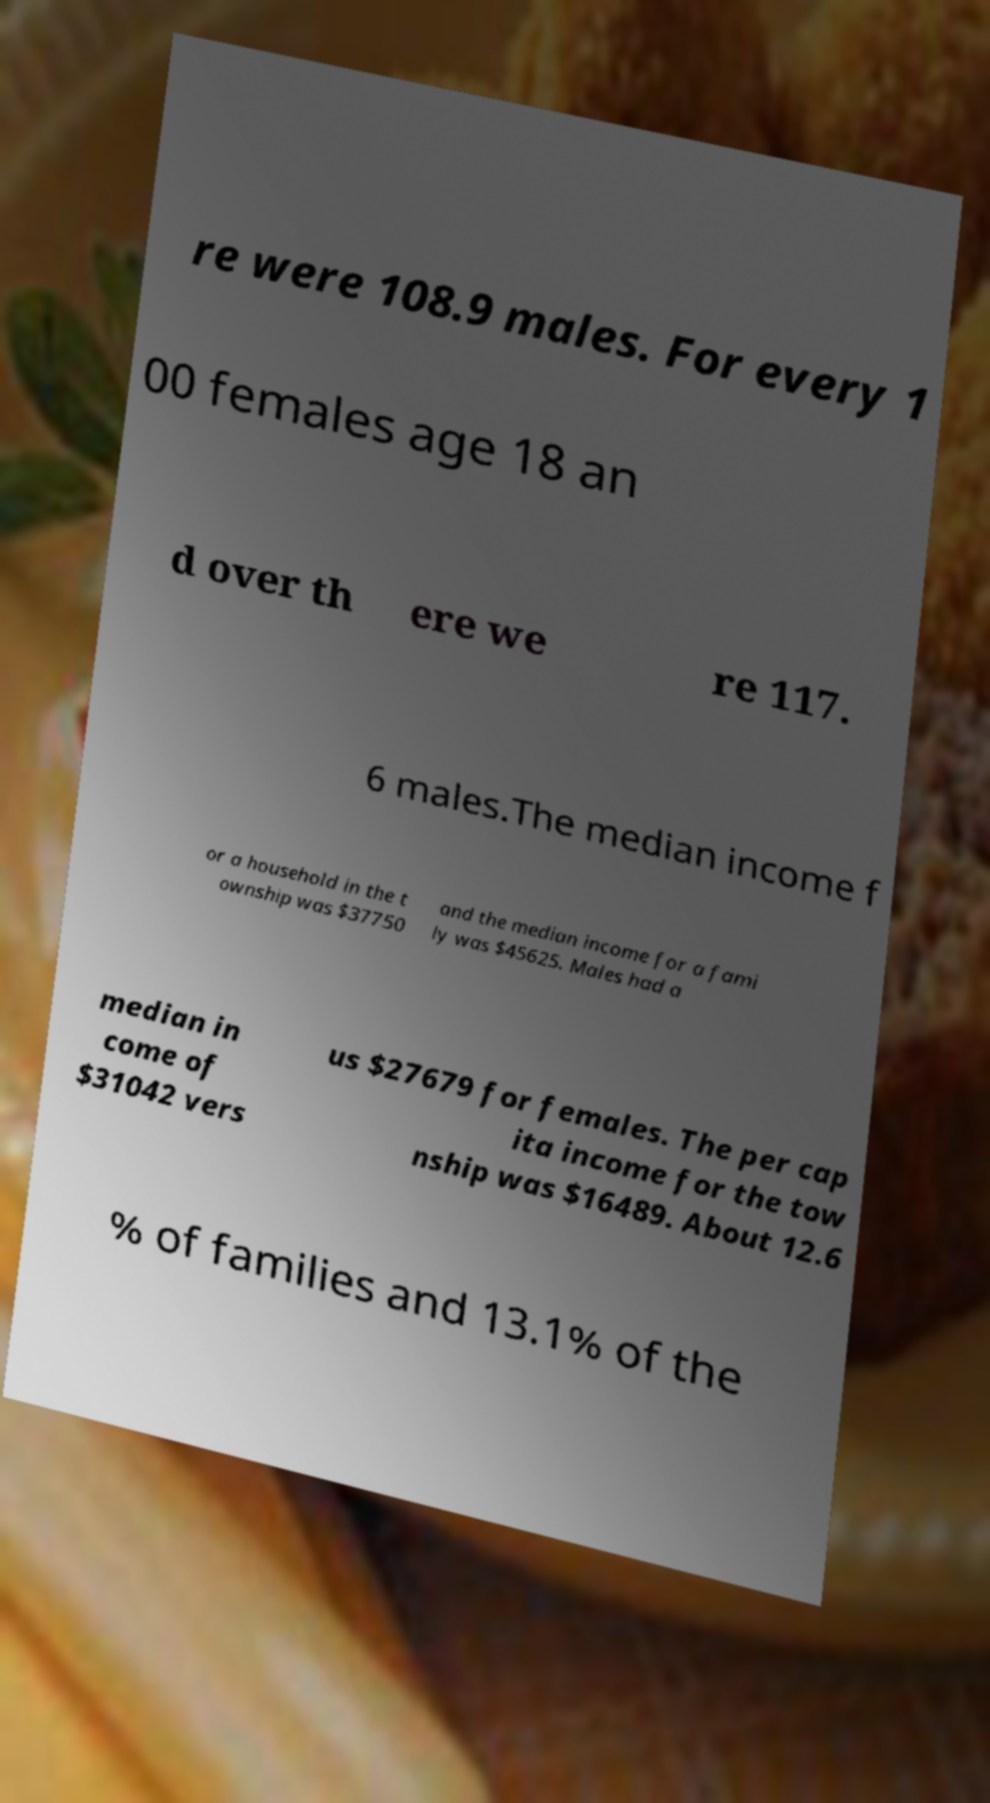There's text embedded in this image that I need extracted. Can you transcribe it verbatim? re were 108.9 males. For every 1 00 females age 18 an d over th ere we re 117. 6 males.The median income f or a household in the t ownship was $37750 and the median income for a fami ly was $45625. Males had a median in come of $31042 vers us $27679 for females. The per cap ita income for the tow nship was $16489. About 12.6 % of families and 13.1% of the 